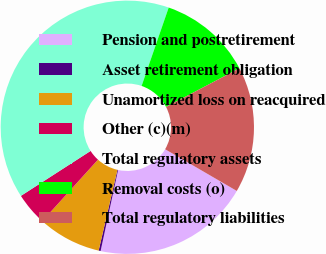<chart> <loc_0><loc_0><loc_500><loc_500><pie_chart><fcel>Pension and postretirement<fcel>Asset retirement obligation<fcel>Unamortized loss on reacquired<fcel>Other (c)(m)<fcel>Total regulatory assets<fcel>Removal costs (o)<fcel>Total regulatory liabilities<nl><fcel>20.0%<fcel>0.25%<fcel>8.08%<fcel>4.17%<fcel>39.41%<fcel>12.0%<fcel>16.09%<nl></chart> 